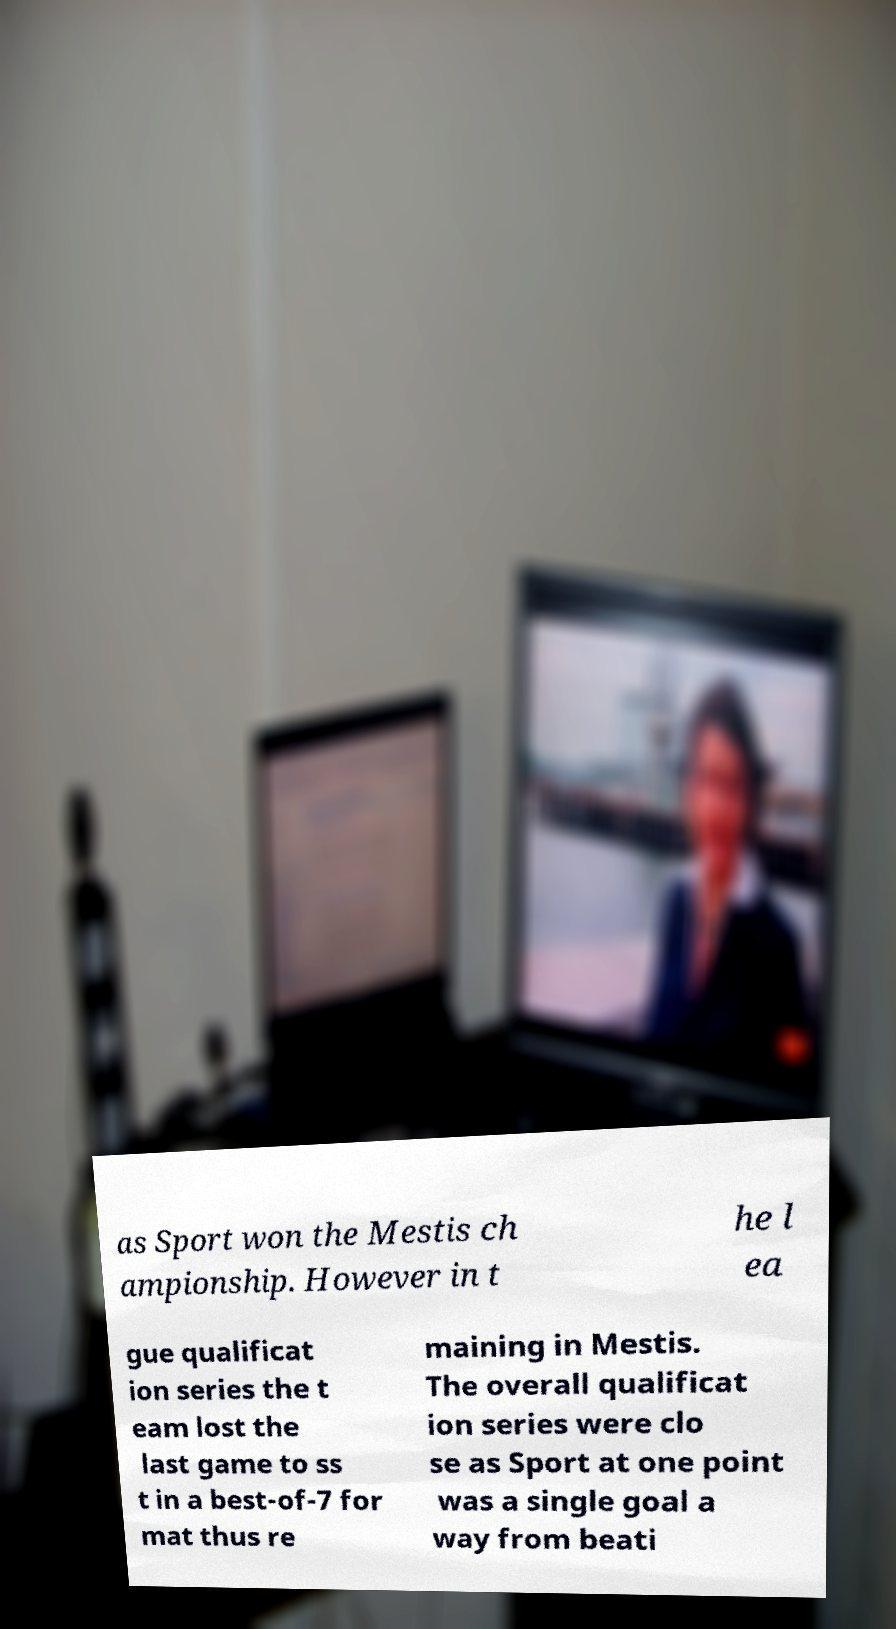What messages or text are displayed in this image? I need them in a readable, typed format. as Sport won the Mestis ch ampionship. However in t he l ea gue qualificat ion series the t eam lost the last game to ss t in a best-of-7 for mat thus re maining in Mestis. The overall qualificat ion series were clo se as Sport at one point was a single goal a way from beati 